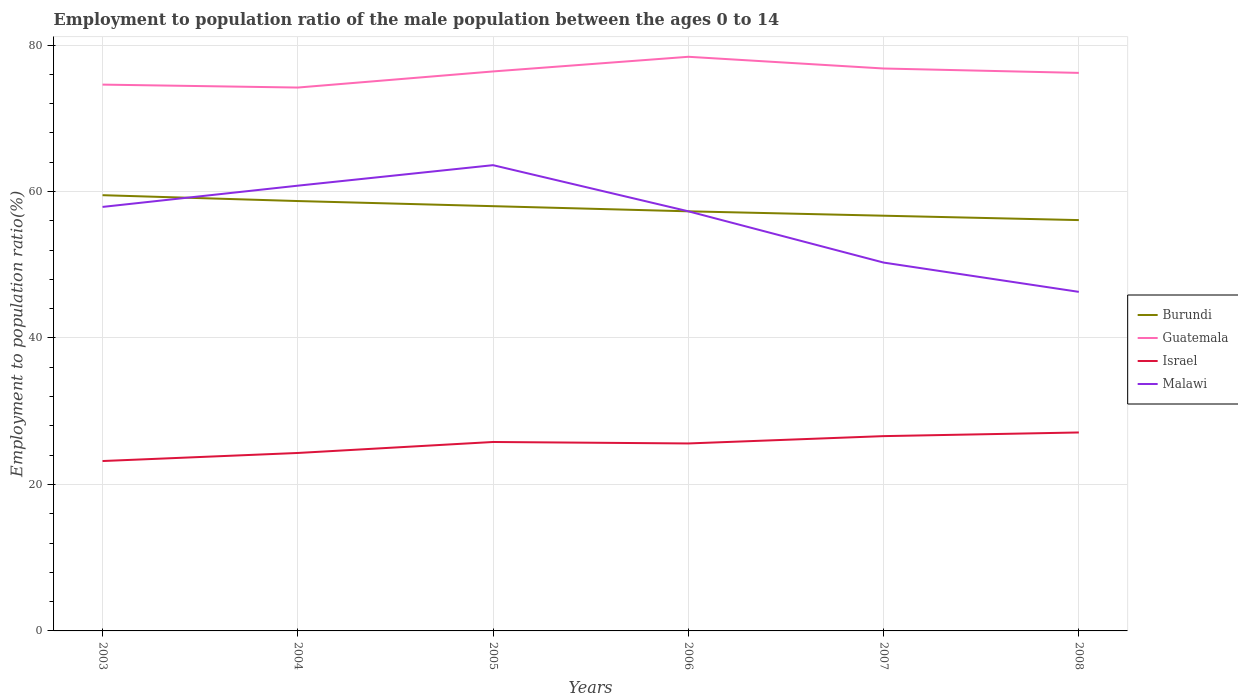How many different coloured lines are there?
Offer a terse response. 4. Is the number of lines equal to the number of legend labels?
Offer a very short reply. Yes. Across all years, what is the maximum employment to population ratio in Burundi?
Give a very brief answer. 56.1. What is the total employment to population ratio in Malawi in the graph?
Make the answer very short. 3.5. What is the difference between the highest and the second highest employment to population ratio in Guatemala?
Offer a very short reply. 4.2. What is the difference between the highest and the lowest employment to population ratio in Burundi?
Your answer should be compact. 3. Is the employment to population ratio in Israel strictly greater than the employment to population ratio in Guatemala over the years?
Give a very brief answer. Yes. Are the values on the major ticks of Y-axis written in scientific E-notation?
Your answer should be very brief. No. Does the graph contain any zero values?
Offer a terse response. No. Where does the legend appear in the graph?
Your response must be concise. Center right. What is the title of the graph?
Offer a terse response. Employment to population ratio of the male population between the ages 0 to 14. Does "Thailand" appear as one of the legend labels in the graph?
Offer a very short reply. No. What is the label or title of the Y-axis?
Offer a terse response. Employment to population ratio(%). What is the Employment to population ratio(%) of Burundi in 2003?
Your response must be concise. 59.5. What is the Employment to population ratio(%) in Guatemala in 2003?
Your response must be concise. 74.6. What is the Employment to population ratio(%) of Israel in 2003?
Provide a succinct answer. 23.2. What is the Employment to population ratio(%) in Malawi in 2003?
Your answer should be very brief. 57.9. What is the Employment to population ratio(%) of Burundi in 2004?
Your response must be concise. 58.7. What is the Employment to population ratio(%) of Guatemala in 2004?
Offer a terse response. 74.2. What is the Employment to population ratio(%) in Israel in 2004?
Your answer should be very brief. 24.3. What is the Employment to population ratio(%) of Malawi in 2004?
Your answer should be very brief. 60.8. What is the Employment to population ratio(%) in Burundi in 2005?
Offer a very short reply. 58. What is the Employment to population ratio(%) in Guatemala in 2005?
Keep it short and to the point. 76.4. What is the Employment to population ratio(%) in Israel in 2005?
Keep it short and to the point. 25.8. What is the Employment to population ratio(%) of Malawi in 2005?
Ensure brevity in your answer.  63.6. What is the Employment to population ratio(%) of Burundi in 2006?
Your answer should be compact. 57.3. What is the Employment to population ratio(%) in Guatemala in 2006?
Your answer should be compact. 78.4. What is the Employment to population ratio(%) in Israel in 2006?
Offer a terse response. 25.6. What is the Employment to population ratio(%) in Malawi in 2006?
Your response must be concise. 57.3. What is the Employment to population ratio(%) of Burundi in 2007?
Offer a very short reply. 56.7. What is the Employment to population ratio(%) of Guatemala in 2007?
Provide a short and direct response. 76.8. What is the Employment to population ratio(%) of Israel in 2007?
Your answer should be very brief. 26.6. What is the Employment to population ratio(%) of Malawi in 2007?
Your answer should be very brief. 50.3. What is the Employment to population ratio(%) of Burundi in 2008?
Your answer should be compact. 56.1. What is the Employment to population ratio(%) of Guatemala in 2008?
Offer a terse response. 76.2. What is the Employment to population ratio(%) in Israel in 2008?
Offer a terse response. 27.1. What is the Employment to population ratio(%) of Malawi in 2008?
Give a very brief answer. 46.3. Across all years, what is the maximum Employment to population ratio(%) in Burundi?
Provide a succinct answer. 59.5. Across all years, what is the maximum Employment to population ratio(%) in Guatemala?
Provide a short and direct response. 78.4. Across all years, what is the maximum Employment to population ratio(%) in Israel?
Keep it short and to the point. 27.1. Across all years, what is the maximum Employment to population ratio(%) in Malawi?
Provide a succinct answer. 63.6. Across all years, what is the minimum Employment to population ratio(%) in Burundi?
Offer a very short reply. 56.1. Across all years, what is the minimum Employment to population ratio(%) of Guatemala?
Provide a succinct answer. 74.2. Across all years, what is the minimum Employment to population ratio(%) of Israel?
Keep it short and to the point. 23.2. Across all years, what is the minimum Employment to population ratio(%) of Malawi?
Ensure brevity in your answer.  46.3. What is the total Employment to population ratio(%) in Burundi in the graph?
Ensure brevity in your answer.  346.3. What is the total Employment to population ratio(%) in Guatemala in the graph?
Your answer should be compact. 456.6. What is the total Employment to population ratio(%) in Israel in the graph?
Your response must be concise. 152.6. What is the total Employment to population ratio(%) of Malawi in the graph?
Provide a succinct answer. 336.2. What is the difference between the Employment to population ratio(%) of Malawi in 2003 and that in 2004?
Keep it short and to the point. -2.9. What is the difference between the Employment to population ratio(%) of Burundi in 2003 and that in 2005?
Your response must be concise. 1.5. What is the difference between the Employment to population ratio(%) of Guatemala in 2003 and that in 2005?
Provide a short and direct response. -1.8. What is the difference between the Employment to population ratio(%) of Israel in 2003 and that in 2006?
Give a very brief answer. -2.4. What is the difference between the Employment to population ratio(%) of Malawi in 2003 and that in 2007?
Make the answer very short. 7.6. What is the difference between the Employment to population ratio(%) of Israel in 2003 and that in 2008?
Ensure brevity in your answer.  -3.9. What is the difference between the Employment to population ratio(%) of Burundi in 2004 and that in 2005?
Ensure brevity in your answer.  0.7. What is the difference between the Employment to population ratio(%) in Guatemala in 2004 and that in 2005?
Your answer should be very brief. -2.2. What is the difference between the Employment to population ratio(%) of Israel in 2004 and that in 2005?
Give a very brief answer. -1.5. What is the difference between the Employment to population ratio(%) of Malawi in 2004 and that in 2005?
Provide a short and direct response. -2.8. What is the difference between the Employment to population ratio(%) in Guatemala in 2004 and that in 2006?
Keep it short and to the point. -4.2. What is the difference between the Employment to population ratio(%) of Malawi in 2004 and that in 2007?
Provide a succinct answer. 10.5. What is the difference between the Employment to population ratio(%) of Burundi in 2004 and that in 2008?
Provide a short and direct response. 2.6. What is the difference between the Employment to population ratio(%) in Israel in 2004 and that in 2008?
Ensure brevity in your answer.  -2.8. What is the difference between the Employment to population ratio(%) in Malawi in 2004 and that in 2008?
Ensure brevity in your answer.  14.5. What is the difference between the Employment to population ratio(%) of Guatemala in 2005 and that in 2006?
Provide a succinct answer. -2. What is the difference between the Employment to population ratio(%) in Malawi in 2005 and that in 2006?
Ensure brevity in your answer.  6.3. What is the difference between the Employment to population ratio(%) in Guatemala in 2005 and that in 2007?
Make the answer very short. -0.4. What is the difference between the Employment to population ratio(%) in Guatemala in 2005 and that in 2008?
Provide a succinct answer. 0.2. What is the difference between the Employment to population ratio(%) in Israel in 2005 and that in 2008?
Your response must be concise. -1.3. What is the difference between the Employment to population ratio(%) in Guatemala in 2006 and that in 2007?
Your answer should be compact. 1.6. What is the difference between the Employment to population ratio(%) of Malawi in 2006 and that in 2007?
Provide a succinct answer. 7. What is the difference between the Employment to population ratio(%) of Guatemala in 2006 and that in 2008?
Your response must be concise. 2.2. What is the difference between the Employment to population ratio(%) of Malawi in 2006 and that in 2008?
Give a very brief answer. 11. What is the difference between the Employment to population ratio(%) in Burundi in 2007 and that in 2008?
Provide a short and direct response. 0.6. What is the difference between the Employment to population ratio(%) in Guatemala in 2007 and that in 2008?
Provide a succinct answer. 0.6. What is the difference between the Employment to population ratio(%) in Burundi in 2003 and the Employment to population ratio(%) in Guatemala in 2004?
Ensure brevity in your answer.  -14.7. What is the difference between the Employment to population ratio(%) of Burundi in 2003 and the Employment to population ratio(%) of Israel in 2004?
Offer a very short reply. 35.2. What is the difference between the Employment to population ratio(%) of Guatemala in 2003 and the Employment to population ratio(%) of Israel in 2004?
Your answer should be compact. 50.3. What is the difference between the Employment to population ratio(%) of Guatemala in 2003 and the Employment to population ratio(%) of Malawi in 2004?
Provide a succinct answer. 13.8. What is the difference between the Employment to population ratio(%) in Israel in 2003 and the Employment to population ratio(%) in Malawi in 2004?
Your answer should be compact. -37.6. What is the difference between the Employment to population ratio(%) in Burundi in 2003 and the Employment to population ratio(%) in Guatemala in 2005?
Keep it short and to the point. -16.9. What is the difference between the Employment to population ratio(%) of Burundi in 2003 and the Employment to population ratio(%) of Israel in 2005?
Your response must be concise. 33.7. What is the difference between the Employment to population ratio(%) of Burundi in 2003 and the Employment to population ratio(%) of Malawi in 2005?
Provide a succinct answer. -4.1. What is the difference between the Employment to population ratio(%) in Guatemala in 2003 and the Employment to population ratio(%) in Israel in 2005?
Provide a succinct answer. 48.8. What is the difference between the Employment to population ratio(%) in Guatemala in 2003 and the Employment to population ratio(%) in Malawi in 2005?
Your response must be concise. 11. What is the difference between the Employment to population ratio(%) of Israel in 2003 and the Employment to population ratio(%) of Malawi in 2005?
Your answer should be compact. -40.4. What is the difference between the Employment to population ratio(%) in Burundi in 2003 and the Employment to population ratio(%) in Guatemala in 2006?
Your answer should be very brief. -18.9. What is the difference between the Employment to population ratio(%) of Burundi in 2003 and the Employment to population ratio(%) of Israel in 2006?
Offer a very short reply. 33.9. What is the difference between the Employment to population ratio(%) of Burundi in 2003 and the Employment to population ratio(%) of Malawi in 2006?
Offer a terse response. 2.2. What is the difference between the Employment to population ratio(%) of Guatemala in 2003 and the Employment to population ratio(%) of Israel in 2006?
Your answer should be very brief. 49. What is the difference between the Employment to population ratio(%) of Israel in 2003 and the Employment to population ratio(%) of Malawi in 2006?
Your response must be concise. -34.1. What is the difference between the Employment to population ratio(%) of Burundi in 2003 and the Employment to population ratio(%) of Guatemala in 2007?
Give a very brief answer. -17.3. What is the difference between the Employment to population ratio(%) of Burundi in 2003 and the Employment to population ratio(%) of Israel in 2007?
Provide a succinct answer. 32.9. What is the difference between the Employment to population ratio(%) of Guatemala in 2003 and the Employment to population ratio(%) of Israel in 2007?
Offer a terse response. 48. What is the difference between the Employment to population ratio(%) of Guatemala in 2003 and the Employment to population ratio(%) of Malawi in 2007?
Your answer should be compact. 24.3. What is the difference between the Employment to population ratio(%) in Israel in 2003 and the Employment to population ratio(%) in Malawi in 2007?
Your answer should be compact. -27.1. What is the difference between the Employment to population ratio(%) of Burundi in 2003 and the Employment to population ratio(%) of Guatemala in 2008?
Provide a short and direct response. -16.7. What is the difference between the Employment to population ratio(%) of Burundi in 2003 and the Employment to population ratio(%) of Israel in 2008?
Ensure brevity in your answer.  32.4. What is the difference between the Employment to population ratio(%) of Guatemala in 2003 and the Employment to population ratio(%) of Israel in 2008?
Provide a short and direct response. 47.5. What is the difference between the Employment to population ratio(%) of Guatemala in 2003 and the Employment to population ratio(%) of Malawi in 2008?
Offer a terse response. 28.3. What is the difference between the Employment to population ratio(%) in Israel in 2003 and the Employment to population ratio(%) in Malawi in 2008?
Offer a very short reply. -23.1. What is the difference between the Employment to population ratio(%) in Burundi in 2004 and the Employment to population ratio(%) in Guatemala in 2005?
Offer a terse response. -17.7. What is the difference between the Employment to population ratio(%) of Burundi in 2004 and the Employment to population ratio(%) of Israel in 2005?
Provide a succinct answer. 32.9. What is the difference between the Employment to population ratio(%) of Burundi in 2004 and the Employment to population ratio(%) of Malawi in 2005?
Provide a short and direct response. -4.9. What is the difference between the Employment to population ratio(%) of Guatemala in 2004 and the Employment to population ratio(%) of Israel in 2005?
Provide a short and direct response. 48.4. What is the difference between the Employment to population ratio(%) in Israel in 2004 and the Employment to population ratio(%) in Malawi in 2005?
Make the answer very short. -39.3. What is the difference between the Employment to population ratio(%) in Burundi in 2004 and the Employment to population ratio(%) in Guatemala in 2006?
Your answer should be very brief. -19.7. What is the difference between the Employment to population ratio(%) in Burundi in 2004 and the Employment to population ratio(%) in Israel in 2006?
Offer a terse response. 33.1. What is the difference between the Employment to population ratio(%) of Burundi in 2004 and the Employment to population ratio(%) of Malawi in 2006?
Offer a very short reply. 1.4. What is the difference between the Employment to population ratio(%) in Guatemala in 2004 and the Employment to population ratio(%) in Israel in 2006?
Provide a short and direct response. 48.6. What is the difference between the Employment to population ratio(%) in Israel in 2004 and the Employment to population ratio(%) in Malawi in 2006?
Offer a very short reply. -33. What is the difference between the Employment to population ratio(%) in Burundi in 2004 and the Employment to population ratio(%) in Guatemala in 2007?
Offer a terse response. -18.1. What is the difference between the Employment to population ratio(%) of Burundi in 2004 and the Employment to population ratio(%) of Israel in 2007?
Your answer should be very brief. 32.1. What is the difference between the Employment to population ratio(%) of Guatemala in 2004 and the Employment to population ratio(%) of Israel in 2007?
Your answer should be very brief. 47.6. What is the difference between the Employment to population ratio(%) of Guatemala in 2004 and the Employment to population ratio(%) of Malawi in 2007?
Ensure brevity in your answer.  23.9. What is the difference between the Employment to population ratio(%) of Burundi in 2004 and the Employment to population ratio(%) of Guatemala in 2008?
Make the answer very short. -17.5. What is the difference between the Employment to population ratio(%) in Burundi in 2004 and the Employment to population ratio(%) in Israel in 2008?
Ensure brevity in your answer.  31.6. What is the difference between the Employment to population ratio(%) in Guatemala in 2004 and the Employment to population ratio(%) in Israel in 2008?
Your answer should be compact. 47.1. What is the difference between the Employment to population ratio(%) of Guatemala in 2004 and the Employment to population ratio(%) of Malawi in 2008?
Keep it short and to the point. 27.9. What is the difference between the Employment to population ratio(%) in Israel in 2004 and the Employment to population ratio(%) in Malawi in 2008?
Make the answer very short. -22. What is the difference between the Employment to population ratio(%) in Burundi in 2005 and the Employment to population ratio(%) in Guatemala in 2006?
Offer a terse response. -20.4. What is the difference between the Employment to population ratio(%) of Burundi in 2005 and the Employment to population ratio(%) of Israel in 2006?
Make the answer very short. 32.4. What is the difference between the Employment to population ratio(%) of Guatemala in 2005 and the Employment to population ratio(%) of Israel in 2006?
Provide a short and direct response. 50.8. What is the difference between the Employment to population ratio(%) of Israel in 2005 and the Employment to population ratio(%) of Malawi in 2006?
Provide a succinct answer. -31.5. What is the difference between the Employment to population ratio(%) in Burundi in 2005 and the Employment to population ratio(%) in Guatemala in 2007?
Offer a terse response. -18.8. What is the difference between the Employment to population ratio(%) of Burundi in 2005 and the Employment to population ratio(%) of Israel in 2007?
Your answer should be very brief. 31.4. What is the difference between the Employment to population ratio(%) of Burundi in 2005 and the Employment to population ratio(%) of Malawi in 2007?
Offer a terse response. 7.7. What is the difference between the Employment to population ratio(%) of Guatemala in 2005 and the Employment to population ratio(%) of Israel in 2007?
Your answer should be compact. 49.8. What is the difference between the Employment to population ratio(%) in Guatemala in 2005 and the Employment to population ratio(%) in Malawi in 2007?
Your answer should be very brief. 26.1. What is the difference between the Employment to population ratio(%) of Israel in 2005 and the Employment to population ratio(%) of Malawi in 2007?
Ensure brevity in your answer.  -24.5. What is the difference between the Employment to population ratio(%) of Burundi in 2005 and the Employment to population ratio(%) of Guatemala in 2008?
Give a very brief answer. -18.2. What is the difference between the Employment to population ratio(%) of Burundi in 2005 and the Employment to population ratio(%) of Israel in 2008?
Your answer should be very brief. 30.9. What is the difference between the Employment to population ratio(%) of Burundi in 2005 and the Employment to population ratio(%) of Malawi in 2008?
Offer a terse response. 11.7. What is the difference between the Employment to population ratio(%) in Guatemala in 2005 and the Employment to population ratio(%) in Israel in 2008?
Your answer should be very brief. 49.3. What is the difference between the Employment to population ratio(%) in Guatemala in 2005 and the Employment to population ratio(%) in Malawi in 2008?
Keep it short and to the point. 30.1. What is the difference between the Employment to population ratio(%) in Israel in 2005 and the Employment to population ratio(%) in Malawi in 2008?
Offer a very short reply. -20.5. What is the difference between the Employment to population ratio(%) in Burundi in 2006 and the Employment to population ratio(%) in Guatemala in 2007?
Your response must be concise. -19.5. What is the difference between the Employment to population ratio(%) of Burundi in 2006 and the Employment to population ratio(%) of Israel in 2007?
Your answer should be compact. 30.7. What is the difference between the Employment to population ratio(%) of Guatemala in 2006 and the Employment to population ratio(%) of Israel in 2007?
Your answer should be compact. 51.8. What is the difference between the Employment to population ratio(%) of Guatemala in 2006 and the Employment to population ratio(%) of Malawi in 2007?
Provide a short and direct response. 28.1. What is the difference between the Employment to population ratio(%) of Israel in 2006 and the Employment to population ratio(%) of Malawi in 2007?
Your answer should be very brief. -24.7. What is the difference between the Employment to population ratio(%) in Burundi in 2006 and the Employment to population ratio(%) in Guatemala in 2008?
Your response must be concise. -18.9. What is the difference between the Employment to population ratio(%) in Burundi in 2006 and the Employment to population ratio(%) in Israel in 2008?
Your answer should be very brief. 30.2. What is the difference between the Employment to population ratio(%) of Burundi in 2006 and the Employment to population ratio(%) of Malawi in 2008?
Your answer should be very brief. 11. What is the difference between the Employment to population ratio(%) of Guatemala in 2006 and the Employment to population ratio(%) of Israel in 2008?
Provide a succinct answer. 51.3. What is the difference between the Employment to population ratio(%) in Guatemala in 2006 and the Employment to population ratio(%) in Malawi in 2008?
Keep it short and to the point. 32.1. What is the difference between the Employment to population ratio(%) of Israel in 2006 and the Employment to population ratio(%) of Malawi in 2008?
Offer a very short reply. -20.7. What is the difference between the Employment to population ratio(%) in Burundi in 2007 and the Employment to population ratio(%) in Guatemala in 2008?
Your response must be concise. -19.5. What is the difference between the Employment to population ratio(%) in Burundi in 2007 and the Employment to population ratio(%) in Israel in 2008?
Your response must be concise. 29.6. What is the difference between the Employment to population ratio(%) of Burundi in 2007 and the Employment to population ratio(%) of Malawi in 2008?
Give a very brief answer. 10.4. What is the difference between the Employment to population ratio(%) in Guatemala in 2007 and the Employment to population ratio(%) in Israel in 2008?
Offer a terse response. 49.7. What is the difference between the Employment to population ratio(%) in Guatemala in 2007 and the Employment to population ratio(%) in Malawi in 2008?
Offer a very short reply. 30.5. What is the difference between the Employment to population ratio(%) of Israel in 2007 and the Employment to population ratio(%) of Malawi in 2008?
Offer a very short reply. -19.7. What is the average Employment to population ratio(%) in Burundi per year?
Make the answer very short. 57.72. What is the average Employment to population ratio(%) of Guatemala per year?
Make the answer very short. 76.1. What is the average Employment to population ratio(%) of Israel per year?
Your response must be concise. 25.43. What is the average Employment to population ratio(%) in Malawi per year?
Your answer should be very brief. 56.03. In the year 2003, what is the difference between the Employment to population ratio(%) of Burundi and Employment to population ratio(%) of Guatemala?
Give a very brief answer. -15.1. In the year 2003, what is the difference between the Employment to population ratio(%) in Burundi and Employment to population ratio(%) in Israel?
Give a very brief answer. 36.3. In the year 2003, what is the difference between the Employment to population ratio(%) of Guatemala and Employment to population ratio(%) of Israel?
Keep it short and to the point. 51.4. In the year 2003, what is the difference between the Employment to population ratio(%) of Israel and Employment to population ratio(%) of Malawi?
Give a very brief answer. -34.7. In the year 2004, what is the difference between the Employment to population ratio(%) in Burundi and Employment to population ratio(%) in Guatemala?
Your answer should be compact. -15.5. In the year 2004, what is the difference between the Employment to population ratio(%) of Burundi and Employment to population ratio(%) of Israel?
Keep it short and to the point. 34.4. In the year 2004, what is the difference between the Employment to population ratio(%) of Burundi and Employment to population ratio(%) of Malawi?
Keep it short and to the point. -2.1. In the year 2004, what is the difference between the Employment to population ratio(%) of Guatemala and Employment to population ratio(%) of Israel?
Offer a terse response. 49.9. In the year 2004, what is the difference between the Employment to population ratio(%) in Israel and Employment to population ratio(%) in Malawi?
Your answer should be very brief. -36.5. In the year 2005, what is the difference between the Employment to population ratio(%) of Burundi and Employment to population ratio(%) of Guatemala?
Make the answer very short. -18.4. In the year 2005, what is the difference between the Employment to population ratio(%) of Burundi and Employment to population ratio(%) of Israel?
Your response must be concise. 32.2. In the year 2005, what is the difference between the Employment to population ratio(%) of Burundi and Employment to population ratio(%) of Malawi?
Keep it short and to the point. -5.6. In the year 2005, what is the difference between the Employment to population ratio(%) of Guatemala and Employment to population ratio(%) of Israel?
Make the answer very short. 50.6. In the year 2005, what is the difference between the Employment to population ratio(%) in Guatemala and Employment to population ratio(%) in Malawi?
Provide a succinct answer. 12.8. In the year 2005, what is the difference between the Employment to population ratio(%) in Israel and Employment to population ratio(%) in Malawi?
Give a very brief answer. -37.8. In the year 2006, what is the difference between the Employment to population ratio(%) in Burundi and Employment to population ratio(%) in Guatemala?
Your answer should be very brief. -21.1. In the year 2006, what is the difference between the Employment to population ratio(%) of Burundi and Employment to population ratio(%) of Israel?
Offer a very short reply. 31.7. In the year 2006, what is the difference between the Employment to population ratio(%) in Guatemala and Employment to population ratio(%) in Israel?
Ensure brevity in your answer.  52.8. In the year 2006, what is the difference between the Employment to population ratio(%) in Guatemala and Employment to population ratio(%) in Malawi?
Ensure brevity in your answer.  21.1. In the year 2006, what is the difference between the Employment to population ratio(%) of Israel and Employment to population ratio(%) of Malawi?
Give a very brief answer. -31.7. In the year 2007, what is the difference between the Employment to population ratio(%) in Burundi and Employment to population ratio(%) in Guatemala?
Provide a short and direct response. -20.1. In the year 2007, what is the difference between the Employment to population ratio(%) of Burundi and Employment to population ratio(%) of Israel?
Your answer should be compact. 30.1. In the year 2007, what is the difference between the Employment to population ratio(%) in Guatemala and Employment to population ratio(%) in Israel?
Offer a very short reply. 50.2. In the year 2007, what is the difference between the Employment to population ratio(%) in Israel and Employment to population ratio(%) in Malawi?
Your answer should be very brief. -23.7. In the year 2008, what is the difference between the Employment to population ratio(%) in Burundi and Employment to population ratio(%) in Guatemala?
Offer a very short reply. -20.1. In the year 2008, what is the difference between the Employment to population ratio(%) of Burundi and Employment to population ratio(%) of Israel?
Offer a terse response. 29. In the year 2008, what is the difference between the Employment to population ratio(%) in Guatemala and Employment to population ratio(%) in Israel?
Offer a terse response. 49.1. In the year 2008, what is the difference between the Employment to population ratio(%) of Guatemala and Employment to population ratio(%) of Malawi?
Your answer should be very brief. 29.9. In the year 2008, what is the difference between the Employment to population ratio(%) in Israel and Employment to population ratio(%) in Malawi?
Keep it short and to the point. -19.2. What is the ratio of the Employment to population ratio(%) of Burundi in 2003 to that in 2004?
Make the answer very short. 1.01. What is the ratio of the Employment to population ratio(%) in Guatemala in 2003 to that in 2004?
Give a very brief answer. 1.01. What is the ratio of the Employment to population ratio(%) in Israel in 2003 to that in 2004?
Ensure brevity in your answer.  0.95. What is the ratio of the Employment to population ratio(%) of Malawi in 2003 to that in 2004?
Offer a very short reply. 0.95. What is the ratio of the Employment to population ratio(%) in Burundi in 2003 to that in 2005?
Keep it short and to the point. 1.03. What is the ratio of the Employment to population ratio(%) in Guatemala in 2003 to that in 2005?
Keep it short and to the point. 0.98. What is the ratio of the Employment to population ratio(%) in Israel in 2003 to that in 2005?
Your answer should be compact. 0.9. What is the ratio of the Employment to population ratio(%) in Malawi in 2003 to that in 2005?
Your answer should be very brief. 0.91. What is the ratio of the Employment to population ratio(%) of Burundi in 2003 to that in 2006?
Your answer should be compact. 1.04. What is the ratio of the Employment to population ratio(%) in Guatemala in 2003 to that in 2006?
Keep it short and to the point. 0.95. What is the ratio of the Employment to population ratio(%) in Israel in 2003 to that in 2006?
Provide a short and direct response. 0.91. What is the ratio of the Employment to population ratio(%) of Malawi in 2003 to that in 2006?
Keep it short and to the point. 1.01. What is the ratio of the Employment to population ratio(%) in Burundi in 2003 to that in 2007?
Keep it short and to the point. 1.05. What is the ratio of the Employment to population ratio(%) in Guatemala in 2003 to that in 2007?
Give a very brief answer. 0.97. What is the ratio of the Employment to population ratio(%) of Israel in 2003 to that in 2007?
Your response must be concise. 0.87. What is the ratio of the Employment to population ratio(%) in Malawi in 2003 to that in 2007?
Ensure brevity in your answer.  1.15. What is the ratio of the Employment to population ratio(%) in Burundi in 2003 to that in 2008?
Your answer should be very brief. 1.06. What is the ratio of the Employment to population ratio(%) of Guatemala in 2003 to that in 2008?
Your response must be concise. 0.98. What is the ratio of the Employment to population ratio(%) in Israel in 2003 to that in 2008?
Keep it short and to the point. 0.86. What is the ratio of the Employment to population ratio(%) of Malawi in 2003 to that in 2008?
Provide a succinct answer. 1.25. What is the ratio of the Employment to population ratio(%) of Burundi in 2004 to that in 2005?
Offer a very short reply. 1.01. What is the ratio of the Employment to population ratio(%) in Guatemala in 2004 to that in 2005?
Give a very brief answer. 0.97. What is the ratio of the Employment to population ratio(%) of Israel in 2004 to that in 2005?
Provide a short and direct response. 0.94. What is the ratio of the Employment to population ratio(%) of Malawi in 2004 to that in 2005?
Offer a very short reply. 0.96. What is the ratio of the Employment to population ratio(%) of Burundi in 2004 to that in 2006?
Offer a very short reply. 1.02. What is the ratio of the Employment to population ratio(%) in Guatemala in 2004 to that in 2006?
Offer a terse response. 0.95. What is the ratio of the Employment to population ratio(%) in Israel in 2004 to that in 2006?
Offer a terse response. 0.95. What is the ratio of the Employment to population ratio(%) of Malawi in 2004 to that in 2006?
Make the answer very short. 1.06. What is the ratio of the Employment to population ratio(%) of Burundi in 2004 to that in 2007?
Offer a terse response. 1.04. What is the ratio of the Employment to population ratio(%) of Guatemala in 2004 to that in 2007?
Offer a terse response. 0.97. What is the ratio of the Employment to population ratio(%) of Israel in 2004 to that in 2007?
Your response must be concise. 0.91. What is the ratio of the Employment to population ratio(%) in Malawi in 2004 to that in 2007?
Give a very brief answer. 1.21. What is the ratio of the Employment to population ratio(%) in Burundi in 2004 to that in 2008?
Keep it short and to the point. 1.05. What is the ratio of the Employment to population ratio(%) of Guatemala in 2004 to that in 2008?
Your answer should be compact. 0.97. What is the ratio of the Employment to population ratio(%) in Israel in 2004 to that in 2008?
Give a very brief answer. 0.9. What is the ratio of the Employment to population ratio(%) of Malawi in 2004 to that in 2008?
Offer a terse response. 1.31. What is the ratio of the Employment to population ratio(%) of Burundi in 2005 to that in 2006?
Give a very brief answer. 1.01. What is the ratio of the Employment to population ratio(%) of Guatemala in 2005 to that in 2006?
Provide a succinct answer. 0.97. What is the ratio of the Employment to population ratio(%) in Malawi in 2005 to that in 2006?
Keep it short and to the point. 1.11. What is the ratio of the Employment to population ratio(%) of Burundi in 2005 to that in 2007?
Your response must be concise. 1.02. What is the ratio of the Employment to population ratio(%) of Guatemala in 2005 to that in 2007?
Your answer should be very brief. 0.99. What is the ratio of the Employment to population ratio(%) of Israel in 2005 to that in 2007?
Make the answer very short. 0.97. What is the ratio of the Employment to population ratio(%) of Malawi in 2005 to that in 2007?
Your response must be concise. 1.26. What is the ratio of the Employment to population ratio(%) of Burundi in 2005 to that in 2008?
Make the answer very short. 1.03. What is the ratio of the Employment to population ratio(%) of Malawi in 2005 to that in 2008?
Offer a very short reply. 1.37. What is the ratio of the Employment to population ratio(%) of Burundi in 2006 to that in 2007?
Offer a very short reply. 1.01. What is the ratio of the Employment to population ratio(%) in Guatemala in 2006 to that in 2007?
Offer a terse response. 1.02. What is the ratio of the Employment to population ratio(%) of Israel in 2006 to that in 2007?
Provide a succinct answer. 0.96. What is the ratio of the Employment to population ratio(%) in Malawi in 2006 to that in 2007?
Ensure brevity in your answer.  1.14. What is the ratio of the Employment to population ratio(%) of Burundi in 2006 to that in 2008?
Give a very brief answer. 1.02. What is the ratio of the Employment to population ratio(%) in Guatemala in 2006 to that in 2008?
Give a very brief answer. 1.03. What is the ratio of the Employment to population ratio(%) of Israel in 2006 to that in 2008?
Keep it short and to the point. 0.94. What is the ratio of the Employment to population ratio(%) in Malawi in 2006 to that in 2008?
Ensure brevity in your answer.  1.24. What is the ratio of the Employment to population ratio(%) of Burundi in 2007 to that in 2008?
Ensure brevity in your answer.  1.01. What is the ratio of the Employment to population ratio(%) of Guatemala in 2007 to that in 2008?
Ensure brevity in your answer.  1.01. What is the ratio of the Employment to population ratio(%) in Israel in 2007 to that in 2008?
Offer a terse response. 0.98. What is the ratio of the Employment to population ratio(%) in Malawi in 2007 to that in 2008?
Make the answer very short. 1.09. What is the difference between the highest and the second highest Employment to population ratio(%) of Burundi?
Ensure brevity in your answer.  0.8. What is the difference between the highest and the second highest Employment to population ratio(%) of Malawi?
Your answer should be very brief. 2.8. What is the difference between the highest and the lowest Employment to population ratio(%) in Burundi?
Make the answer very short. 3.4. What is the difference between the highest and the lowest Employment to population ratio(%) of Guatemala?
Give a very brief answer. 4.2. What is the difference between the highest and the lowest Employment to population ratio(%) in Israel?
Offer a very short reply. 3.9. 